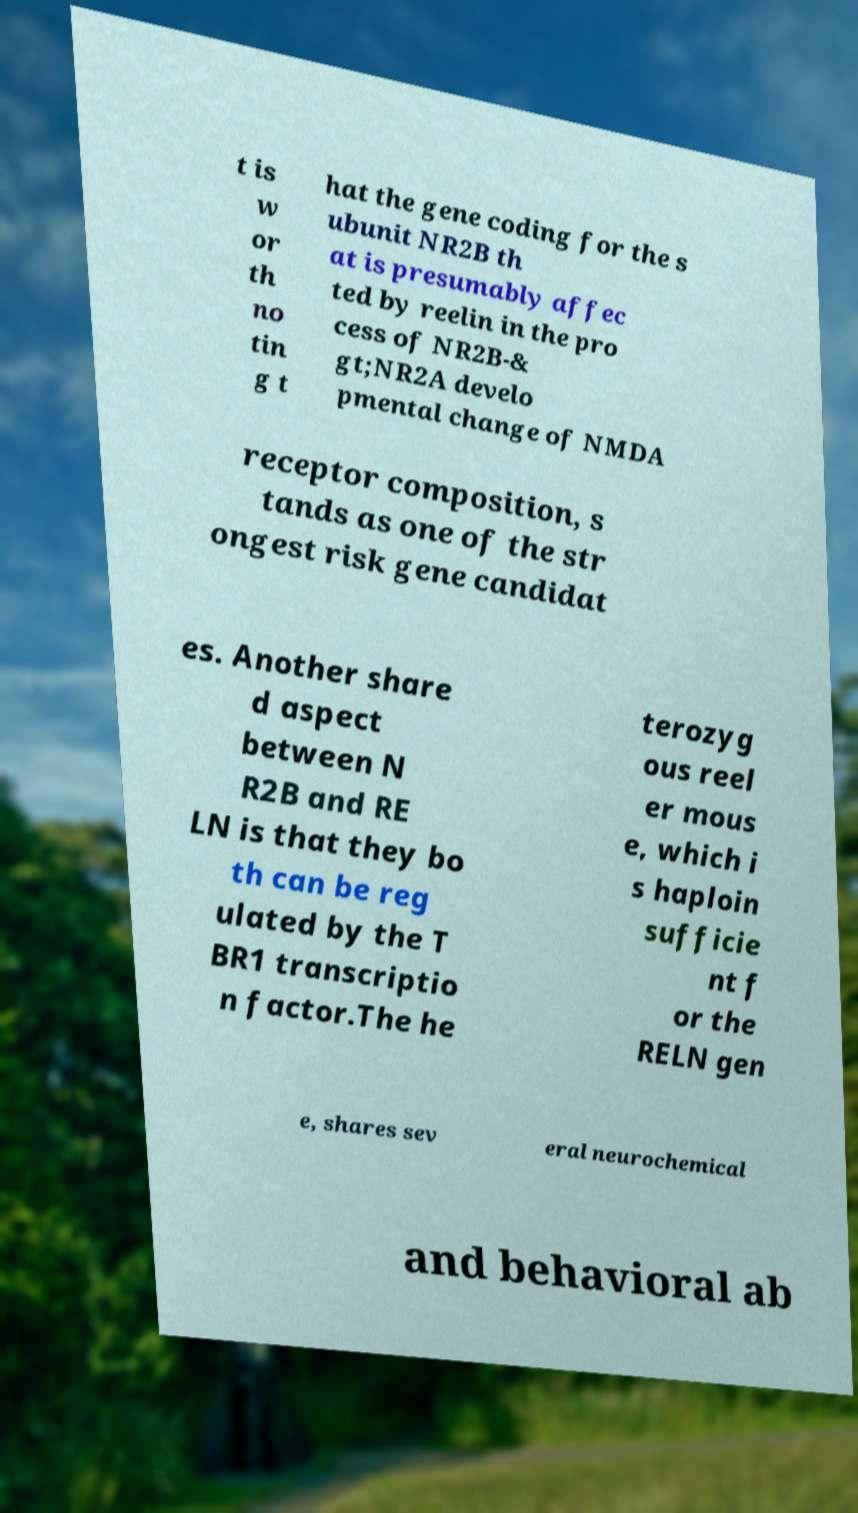I need the written content from this picture converted into text. Can you do that? t is w or th no tin g t hat the gene coding for the s ubunit NR2B th at is presumably affec ted by reelin in the pro cess of NR2B-& gt;NR2A develo pmental change of NMDA receptor composition, s tands as one of the str ongest risk gene candidat es. Another share d aspect between N R2B and RE LN is that they bo th can be reg ulated by the T BR1 transcriptio n factor.The he terozyg ous reel er mous e, which i s haploin sufficie nt f or the RELN gen e, shares sev eral neurochemical and behavioral ab 